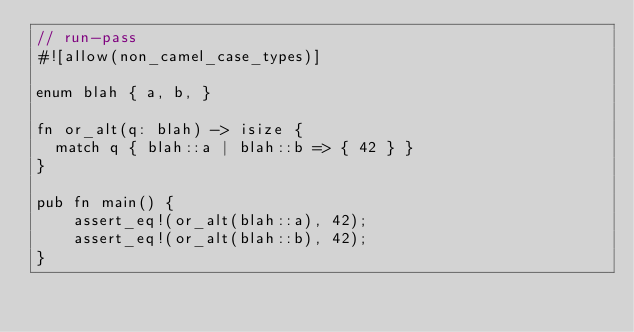<code> <loc_0><loc_0><loc_500><loc_500><_Rust_>// run-pass
#![allow(non_camel_case_types)]

enum blah { a, b, }

fn or_alt(q: blah) -> isize {
  match q { blah::a | blah::b => { 42 } }
}

pub fn main() {
    assert_eq!(or_alt(blah::a), 42);
    assert_eq!(or_alt(blah::b), 42);
}
</code> 